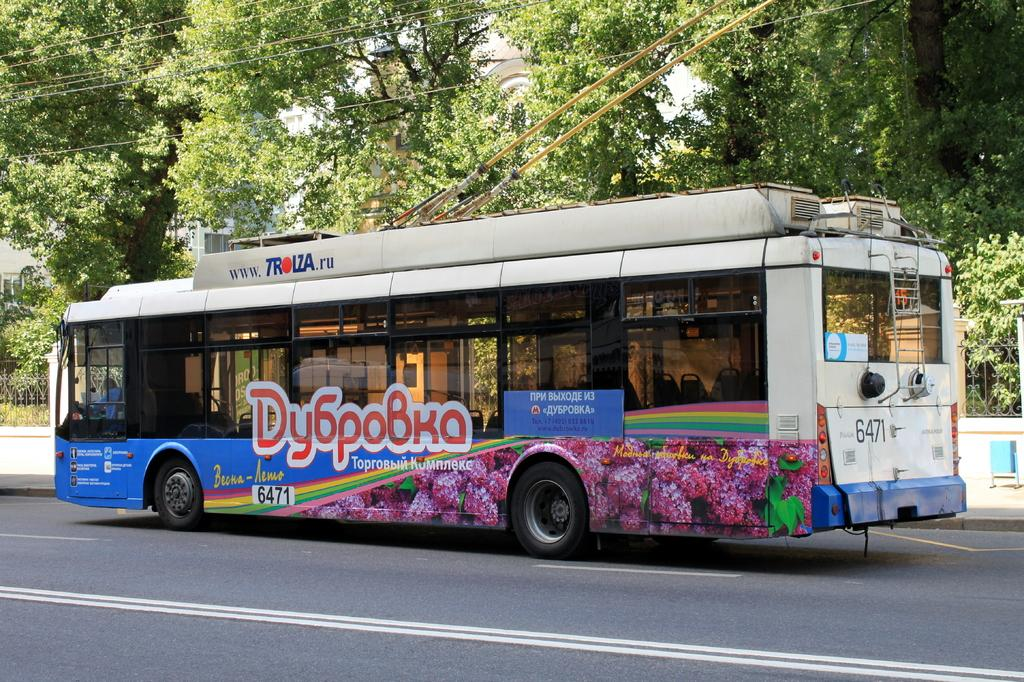What type of vehicle is on the road in the image? There is a bus on the road in the image. What can be seen in the background of the image? There is a building with windows in the image. What type of natural elements are visible in the image? Trees are visible in the image. What type of barrier is present in the image? There is a fence in the image. What part of a tree is visible in the image? The bark of a tree is present in the image. What type of infrastructure is visible in the image? There are wires visible in the image. What type of alarm is going off on the ground in the image? There is no alarm present in the image, and the ground is not mentioned in the provided facts. 